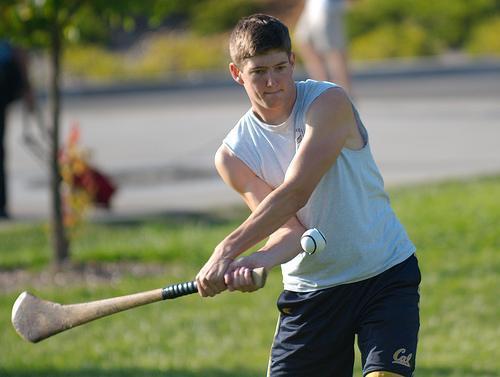How many people are playing football?
Give a very brief answer. 0. 